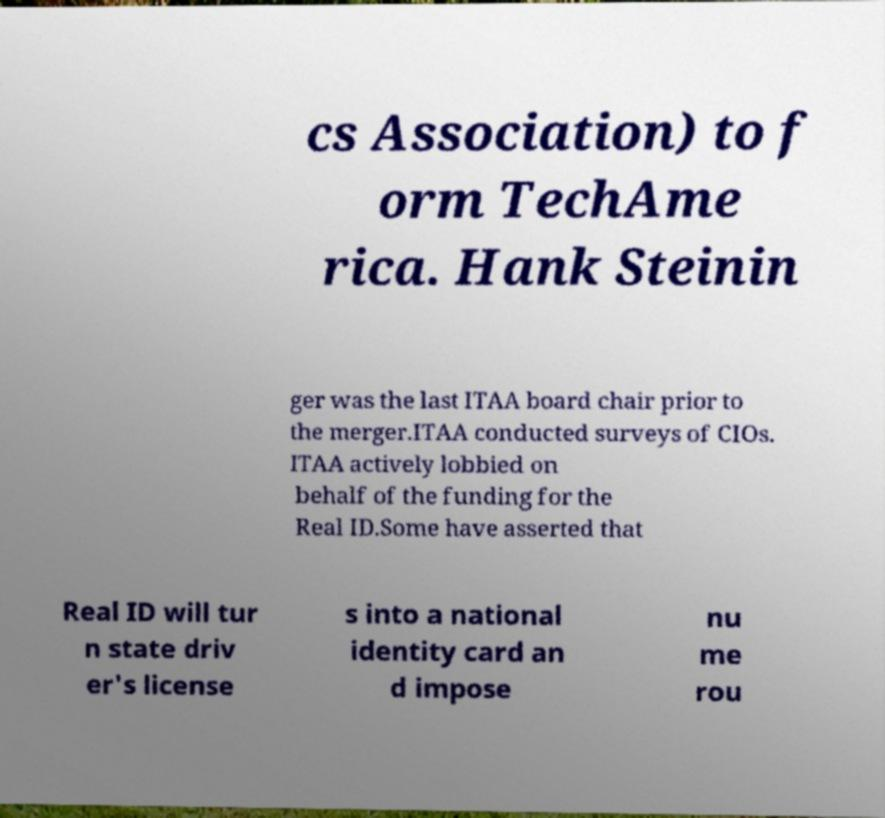For documentation purposes, I need the text within this image transcribed. Could you provide that? cs Association) to f orm TechAme rica. Hank Steinin ger was the last ITAA board chair prior to the merger.ITAA conducted surveys of CIOs. ITAA actively lobbied on behalf of the funding for the Real ID.Some have asserted that Real ID will tur n state driv er's license s into a national identity card an d impose nu me rou 